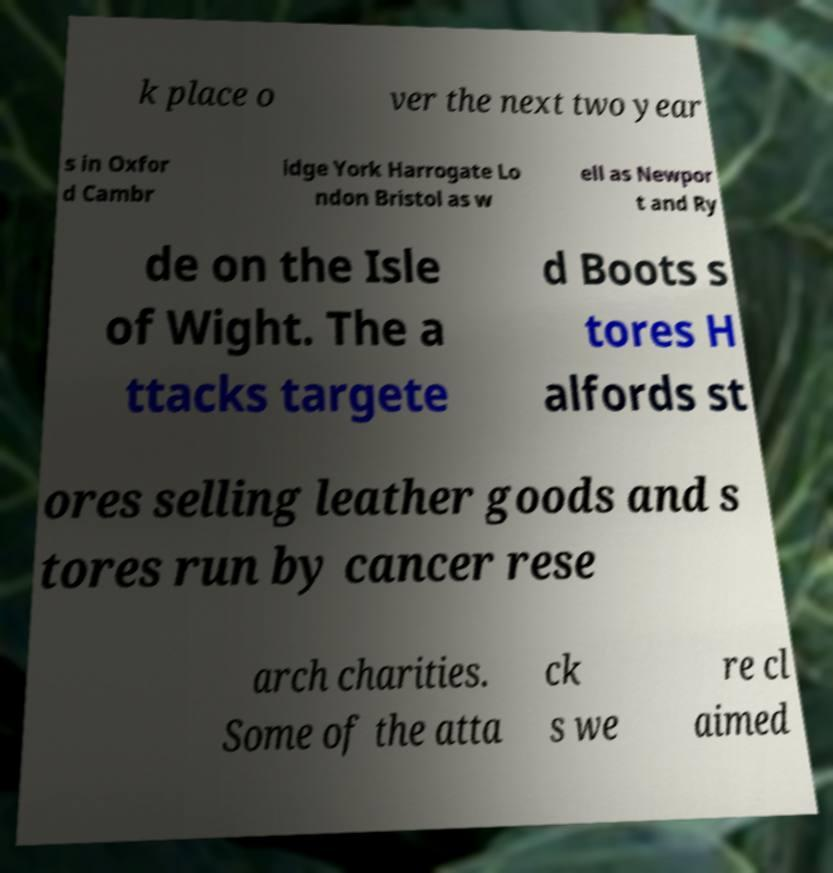For documentation purposes, I need the text within this image transcribed. Could you provide that? k place o ver the next two year s in Oxfor d Cambr idge York Harrogate Lo ndon Bristol as w ell as Newpor t and Ry de on the Isle of Wight. The a ttacks targete d Boots s tores H alfords st ores selling leather goods and s tores run by cancer rese arch charities. Some of the atta ck s we re cl aimed 